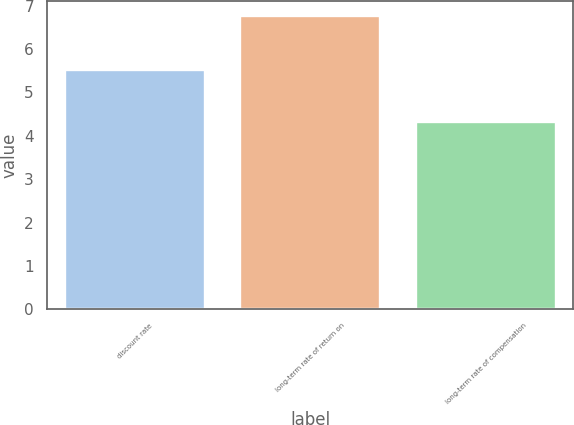Convert chart. <chart><loc_0><loc_0><loc_500><loc_500><bar_chart><fcel>discount rate<fcel>long-term rate of return on<fcel>long-term rate of compensation<nl><fcel>5.52<fcel>6.77<fcel>4.31<nl></chart> 